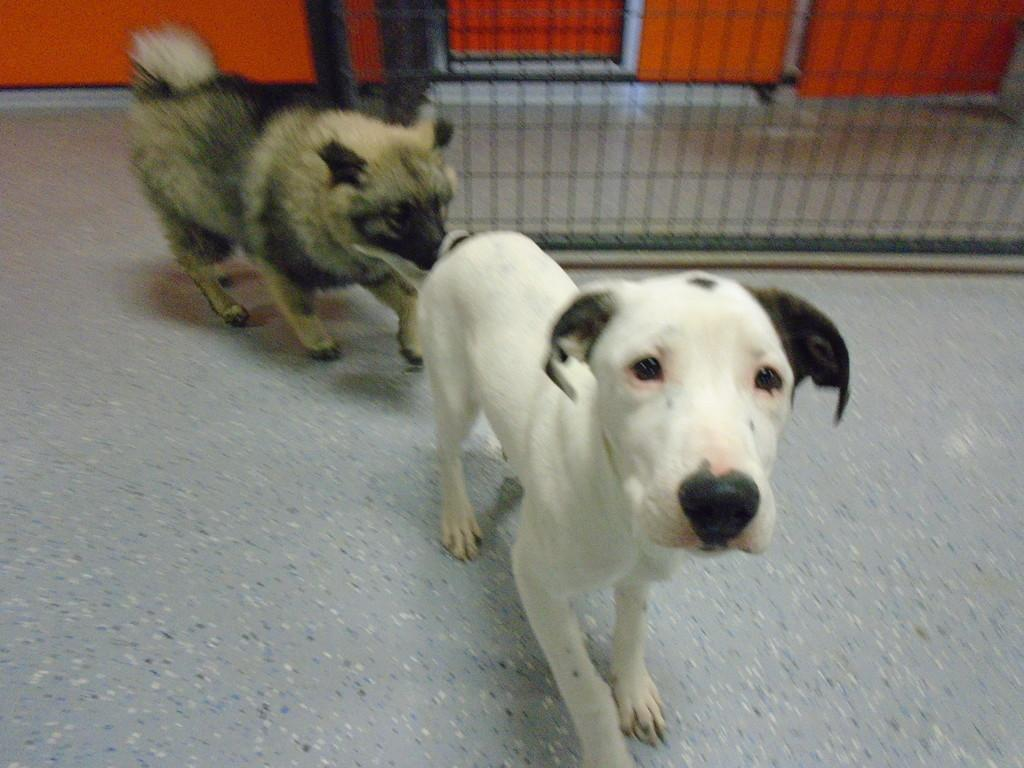What type of animals are in the image? There are dogs in the image. How many dogs can be seen in the image? There are at least two dogs in the image. What is the purpose of the fence in the image? The purpose of the fence in the image is not specified, but it could be to contain the dogs or provide a boundary. What type of authority does the pig have over the dogs in the image? There is no pig present in the image, so it cannot have any authority over the dogs. 